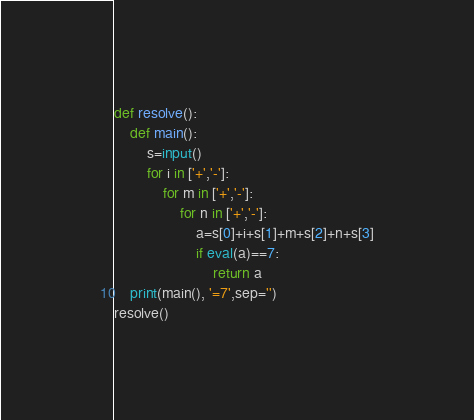<code> <loc_0><loc_0><loc_500><loc_500><_Python_>def resolve():
    def main():
        s=input()
        for i in ['+','-']:
            for m in ['+','-']:
                for n in ['+','-']:
                    a=s[0]+i+s[1]+m+s[2]+n+s[3]
                    if eval(a)==7:
                        return a
    print(main(), '=7',sep='')
resolve()</code> 